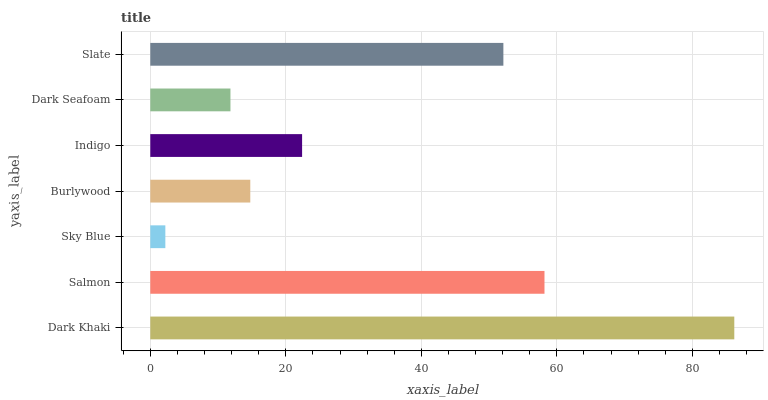Is Sky Blue the minimum?
Answer yes or no. Yes. Is Dark Khaki the maximum?
Answer yes or no. Yes. Is Salmon the minimum?
Answer yes or no. No. Is Salmon the maximum?
Answer yes or no. No. Is Dark Khaki greater than Salmon?
Answer yes or no. Yes. Is Salmon less than Dark Khaki?
Answer yes or no. Yes. Is Salmon greater than Dark Khaki?
Answer yes or no. No. Is Dark Khaki less than Salmon?
Answer yes or no. No. Is Indigo the high median?
Answer yes or no. Yes. Is Indigo the low median?
Answer yes or no. Yes. Is Dark Khaki the high median?
Answer yes or no. No. Is Burlywood the low median?
Answer yes or no. No. 